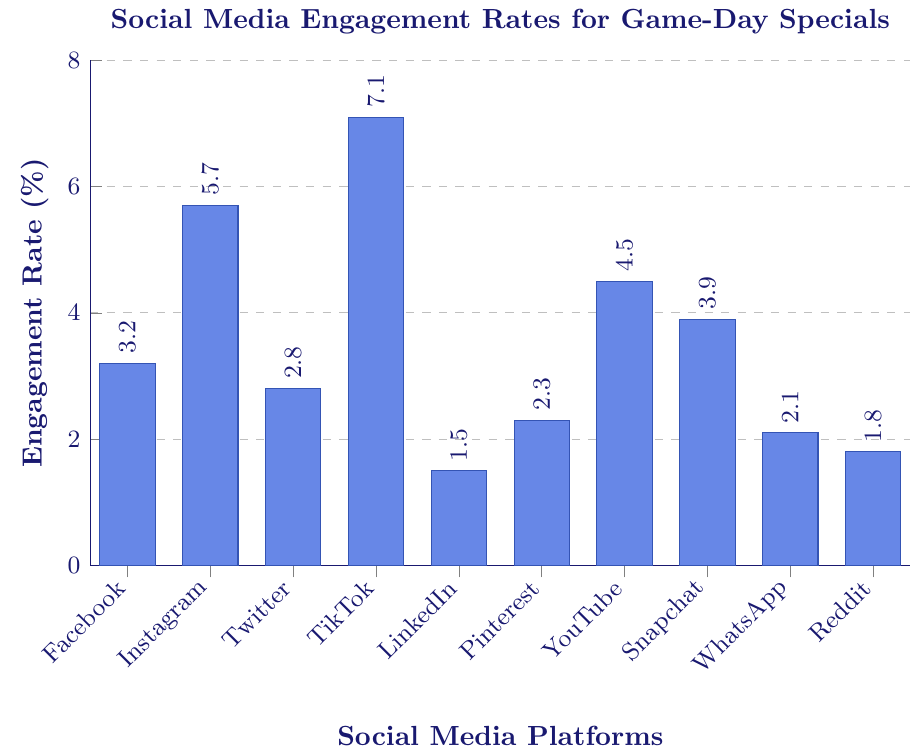Which social media platform has the highest engagement rate for game-day specials? From the bar chart, the tallest bar represents the highest engagement rate. The TikTok bar is the tallest.
Answer: TikTok Which platform has the lowest engagement rate? The lowest engagement rate corresponds to the shortest bar. The bar for LinkedIn is the shortest.
Answer: LinkedIn How much higher is TikTok's engagement rate compared to Facebook's? TikTok's engagement rate is 7.1%, and Facebook's is 3.2%. The difference is 7.1% - 3.2% = 3.9%.
Answer: 3.9% What is the average engagement rate across all platforms? Add all engagement rates (3.2 + 5.7 + 2.8 + 7.1 + 1.5 + 2.3 + 4.5 + 3.9 + 2.1 + 1.8) to get 34.9. Divide by the number of platforms (10): 34.9 / 10 = 3.49%.
Answer: 3.49% What is the combined engagement rate of Pinterest and Snapchat? Pinterest's engagement rate is 2.3%, and Snapchat's is 3.9%. Combine them by adding: 2.3% + 3.9% = 6.2%.
Answer: 6.2% Which two platforms have engagement rates closest to each other? By visually comparing the bars, Facebook (3.2%) and Snapchat (3.9%) have engagement rates that are close, with a difference of 0.7%.
Answer: Facebook and Snapchat How does YouTube's engagement compare to Reddit's in terms of percentage points difference? YouTube's engagement rate is 4.5%, and Reddit's is 1.8%. The difference is 4.5% - 1.8% = 2.7%.
Answer: 2.7% Is the engagement rate of Instagram greater than twice that of LinkedIn? LinkedIn's engagement rate is 1.5%, twice this is 1.5% * 2 = 3%. Instagram’s rate is 5.7%, which is greater than 3%.
Answer: Yes What percentage of the platforms have engagement rates above 4%? Platforms above 4%: Instagram (5.7%), TikTok (7.1%), YouTube (4.5%), Snapchat (3.9%). Count these (4) and divide by total platforms (10): (4/10) * 100 = 40%.
Answer: 40% Rank the platforms in ascending order of engagement rate. Order the engagement rates: LinkedIn (1.5%), Reddit (1.8%), WhatsApp (2.1%), Pinterest (2.3%), Twitter (2.8%), Facebook (3.2%), Snapchat (3.9%), YouTube (4.5%), Instagram (5.7%), TikTok (7.1%).
Answer: LinkedIn, Reddit, WhatsApp, Pinterest, Twitter, Facebook, Snapchat, YouTube, Instagram, TikTok 